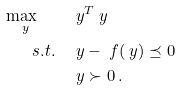Convert formula to latex. <formula><loc_0><loc_0><loc_500><loc_500>\max _ { \ y } \quad & \ y ^ { T } \ y \\ s . t . \quad & \ y - \ f ( \ y ) \preceq 0 \\ & \ y \succ 0 \, .</formula> 